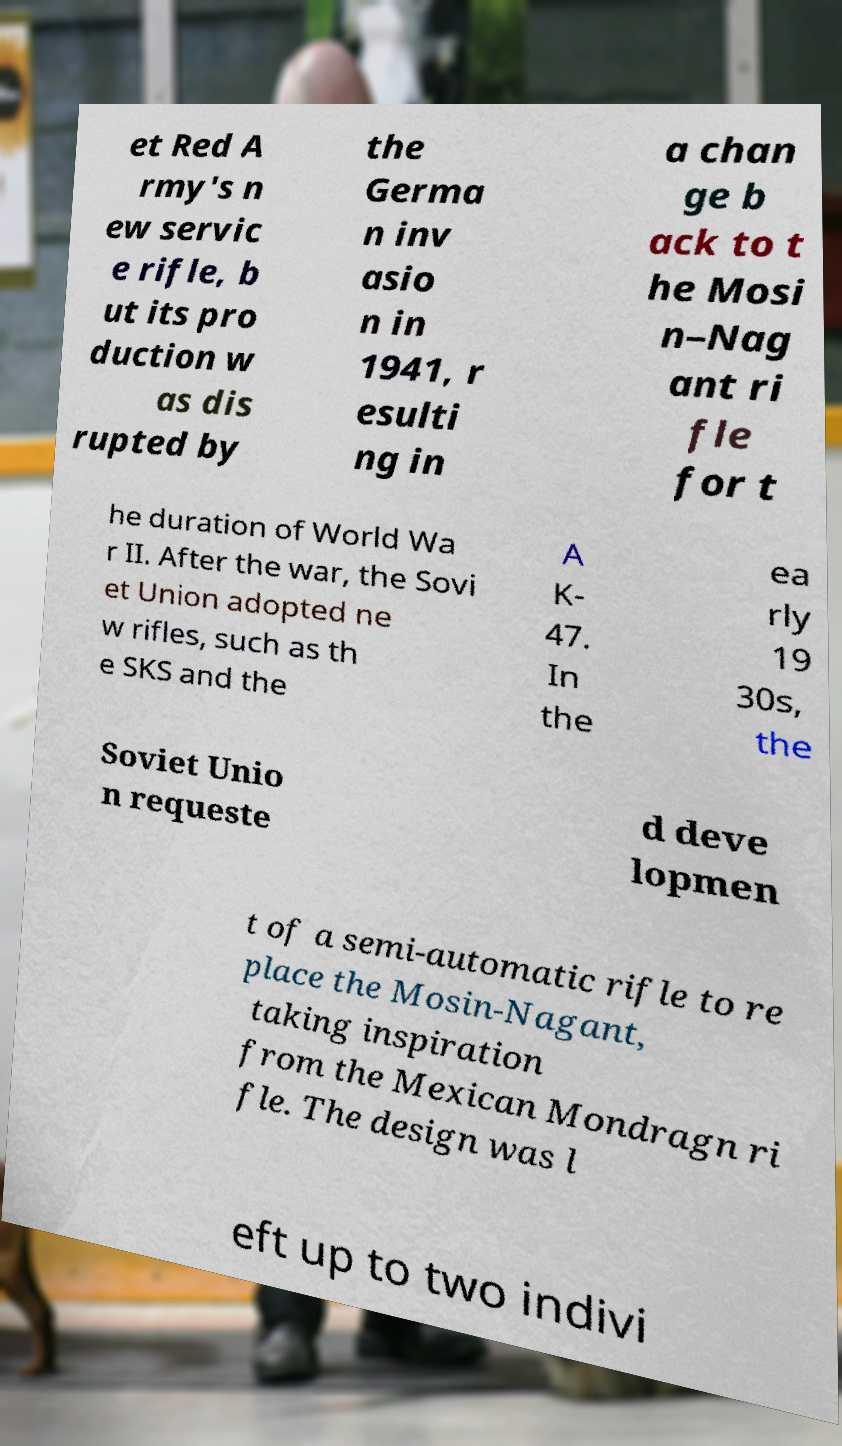For documentation purposes, I need the text within this image transcribed. Could you provide that? et Red A rmy's n ew servic e rifle, b ut its pro duction w as dis rupted by the Germa n inv asio n in 1941, r esulti ng in a chan ge b ack to t he Mosi n–Nag ant ri fle for t he duration of World Wa r II. After the war, the Sovi et Union adopted ne w rifles, such as th e SKS and the A K- 47. In the ea rly 19 30s, the Soviet Unio n requeste d deve lopmen t of a semi-automatic rifle to re place the Mosin-Nagant, taking inspiration from the Mexican Mondragn ri fle. The design was l eft up to two indivi 